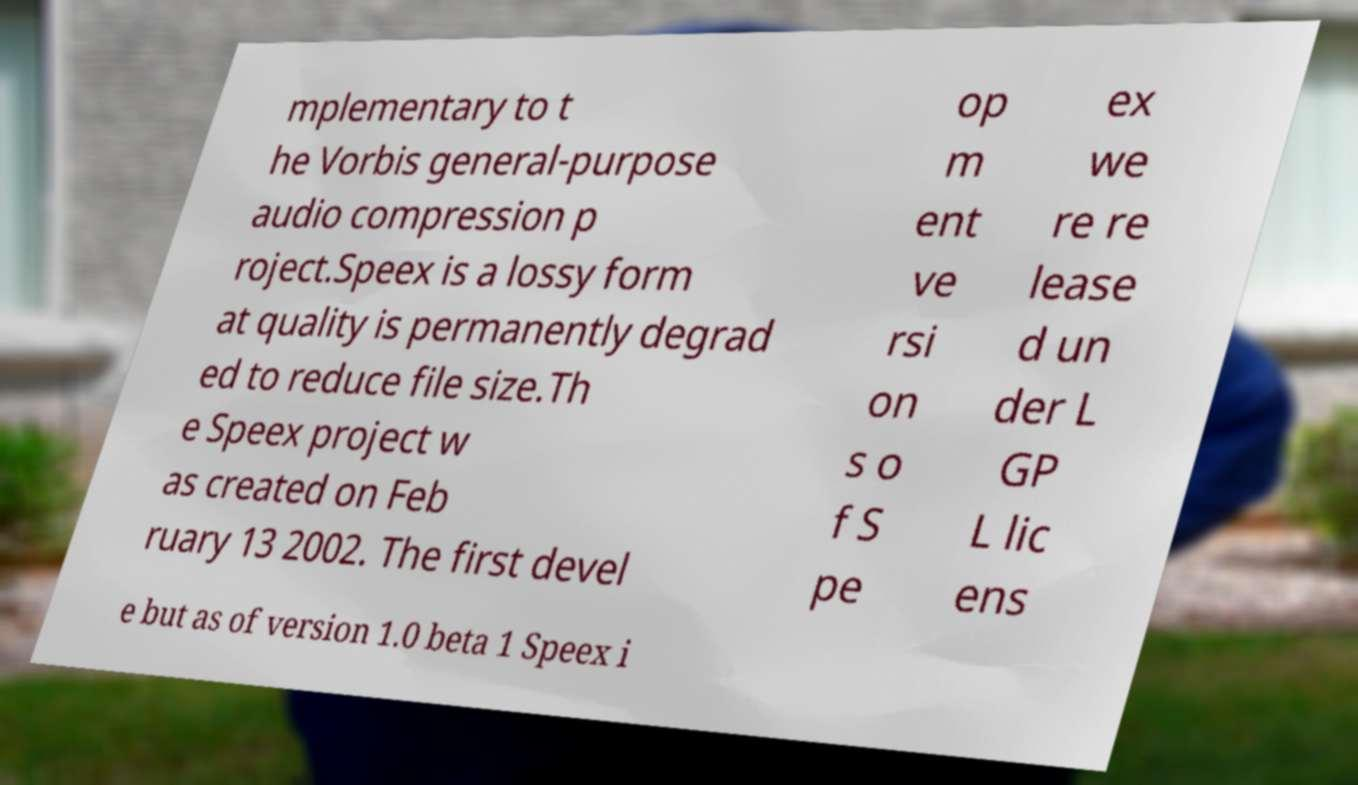What messages or text are displayed in this image? I need them in a readable, typed format. mplementary to t he Vorbis general-purpose audio compression p roject.Speex is a lossy form at quality is permanently degrad ed to reduce file size.Th e Speex project w as created on Feb ruary 13 2002. The first devel op m ent ve rsi on s o f S pe ex we re re lease d un der L GP L lic ens e but as of version 1.0 beta 1 Speex i 